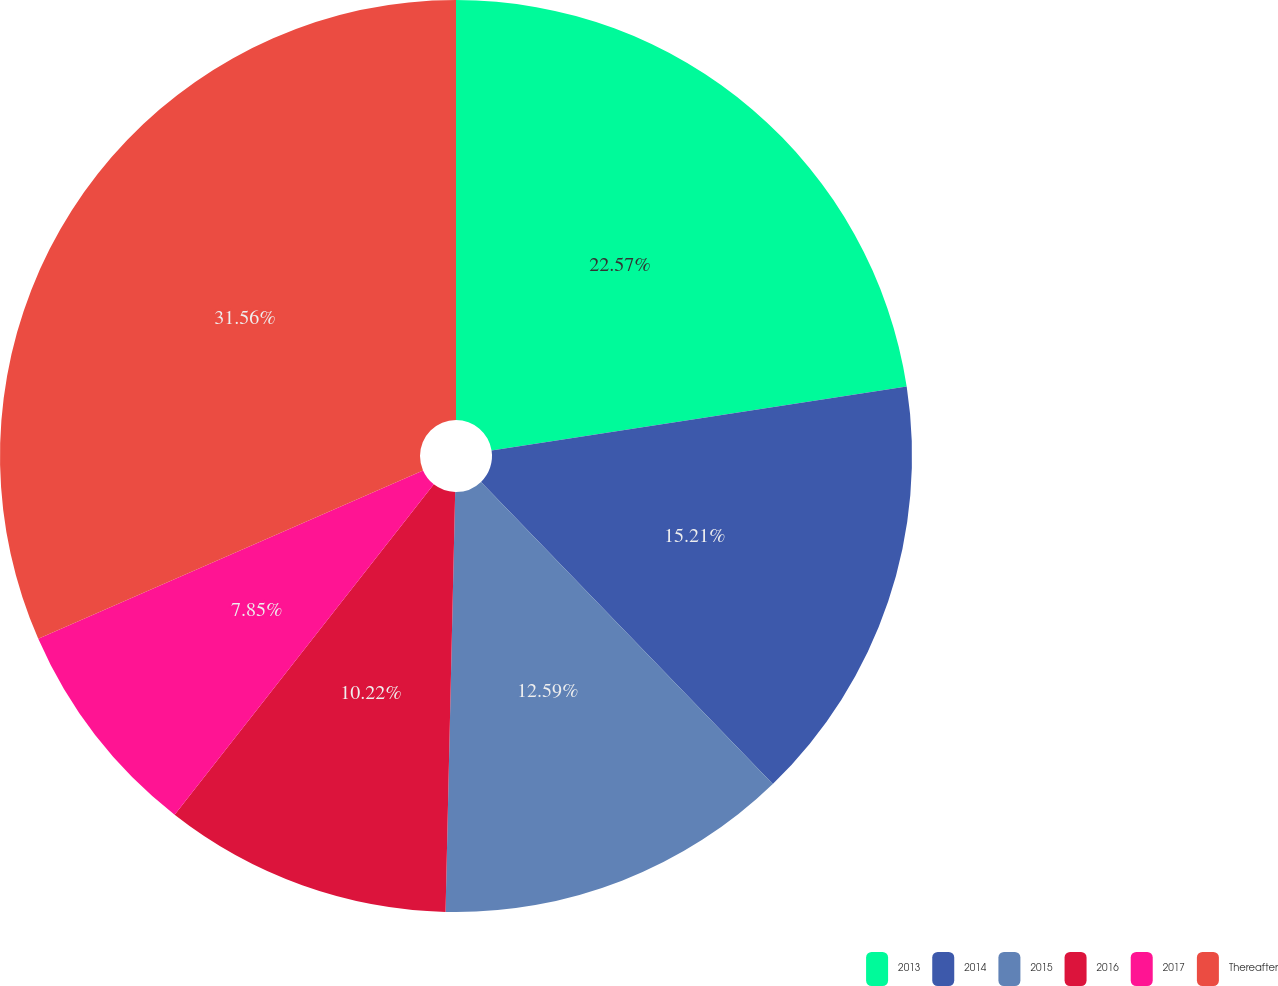Convert chart. <chart><loc_0><loc_0><loc_500><loc_500><pie_chart><fcel>2013<fcel>2014<fcel>2015<fcel>2016<fcel>2017<fcel>Thereafter<nl><fcel>22.57%<fcel>15.21%<fcel>12.59%<fcel>10.22%<fcel>7.85%<fcel>31.57%<nl></chart> 